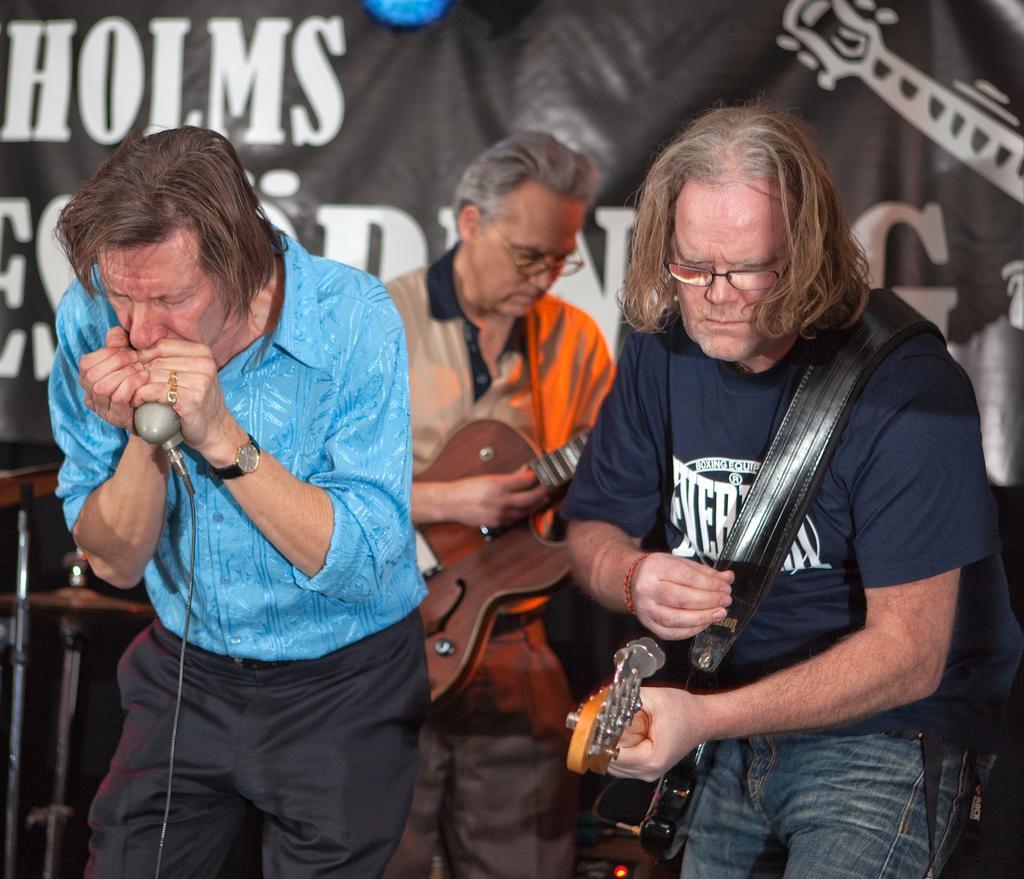How would you summarize this image in a sentence or two? A person wearing a blue shirt and a watch is holding a mic and singing. Another person beside him is holding a guitar. In the other person wearing specs is playing guitar. In the background there is a banner. On the left side there is a cymbal. 